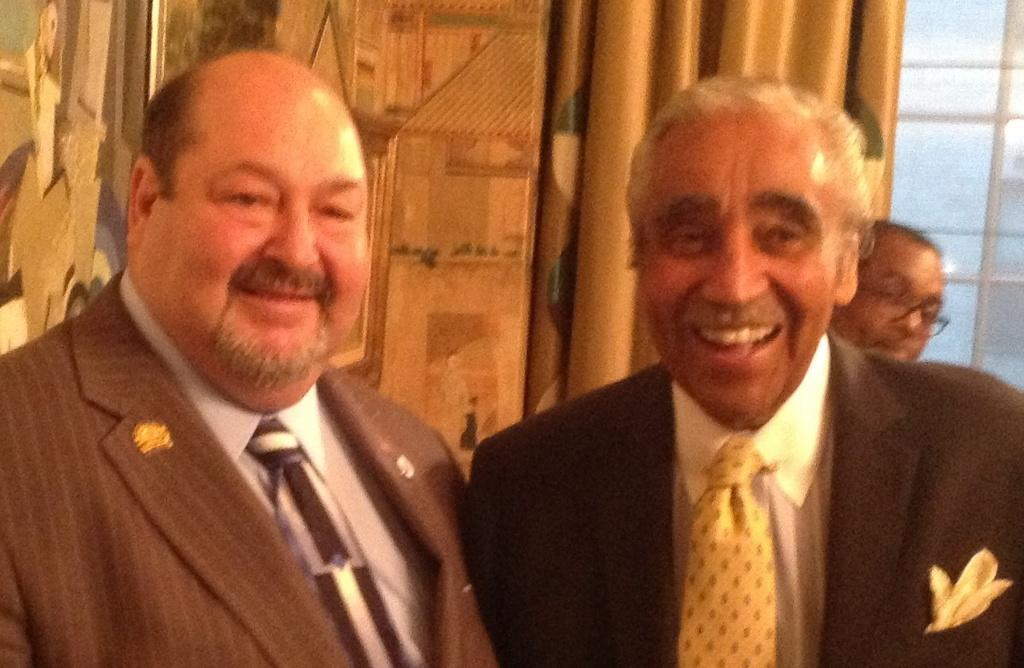How many men are in the image? There are three men in the image. What are the men wearing? Two of the men are wearing suits. What is the facial expression of the men wearing suits? Both men wearing suits are smiling. What can be seen through the window glasses in the image? The details beyond the window glasses are not visible in the image. What color is the curtain in the image? The curtain in the image is golden in color. What type of treatment is the man in the middle receiving for his crime in the image? There is no indication of a crime or any treatment in the image; it features three men, two of whom are wearing suits and smiling. 